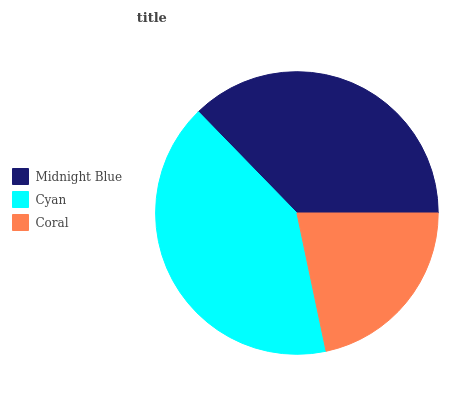Is Coral the minimum?
Answer yes or no. Yes. Is Cyan the maximum?
Answer yes or no. Yes. Is Cyan the minimum?
Answer yes or no. No. Is Coral the maximum?
Answer yes or no. No. Is Cyan greater than Coral?
Answer yes or no. Yes. Is Coral less than Cyan?
Answer yes or no. Yes. Is Coral greater than Cyan?
Answer yes or no. No. Is Cyan less than Coral?
Answer yes or no. No. Is Midnight Blue the high median?
Answer yes or no. Yes. Is Midnight Blue the low median?
Answer yes or no. Yes. Is Coral the high median?
Answer yes or no. No. Is Coral the low median?
Answer yes or no. No. 